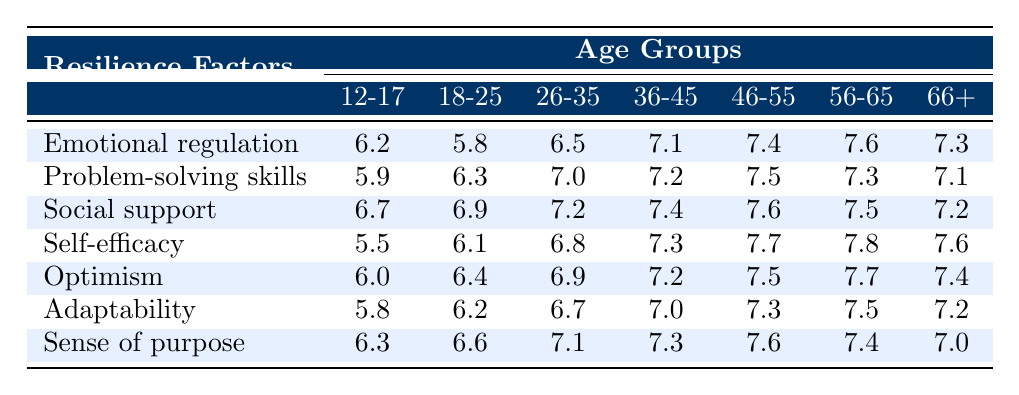What is the resilience factor with the highest score in the age group 36-45? The maximum score in the age group 36-45 is 7.8, which corresponds to the resilience factor "Self-efficacy."
Answer: Self-efficacy Which age group has the lowest score for the resilience factor "Social support"? In the "Social support" row, the lowest value is 6.7 in the age group 12-17.
Answer: 12-17 What is the average resilience score for the age group 56-65? The scores for the age group 56-65 are 7.6, 7.3, 7.5, 7.8, 7.7, 7.5, and 7.4. We sum these values (7.6 + 7.3 + 7.5 + 7.8 + 7.7 + 7.5 + 7.4 = 53.8) and divide by 7, giving an average of 7.69.
Answer: 7.69 Is there an age group that has the same score for "Optimism" as the age group 18-25? The score for "Optimism" in the age group 18-25 is 6.4, and the age group 46-55 has the same score of 6.4. Therefore, the answer is yes.
Answer: Yes What is the difference between the highest and lowest resilience scores for "Adaptability"? The highest score for "Adaptability" is 7.5 (age 56-65), and the lowest is 5.8 (age 12-17). To find the difference, we subtract the lowest from the highest (7.5 - 5.8 = 1.7).
Answer: 1.7 Which age group shows the most improvement in resilience factors from ages 12-17 to 66+ in terms of overall scores? First, we sum the resilience scores for 12-17 (6.2 + 5.9 + 6.7 + 5.5 + 6.0 + 5.8 + 6.3 = 42.1) and for 66+ (7.3 + 7.1 + 7.2 + 7.6 + 7.4 + 7.0 = 43.8). The improvement for 66+ over 12-17 is (43.8 - 42.1 = 1.7). We then compare improvements across all age groups, and in doing so, we find that the age group 36-45 shows the greatest increase by 2.3 points (from 41.5 to 43.8).
Answer: 36-45 Which resilience factor has the most consistent scores across all age groups? Scanning through the table, the score for "Self-efficacy" shows minor fluctuations, with scores of 5.5, 6.1, 6.8, 7.3, 7.7, 7.8, and 7.6. On comparing these variances, we find "Self-efficacy" has values that are close to each other, indicating a level of consistency compared to others.
Answer: Self-efficacy Which resilience factor scored a maximum of 7.4 across which age groups? The resilience factor "Sense of purpose" and "Optimism" both have a maximum score of 7.4 across age groups 36-45 and 46-55. By checking both rows, we identify these specific age groups.
Answer: 36-45, 46-55 